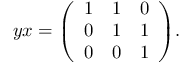<formula> <loc_0><loc_0><loc_500><loc_500>y x = { \left ( \begin{array} { l l l } { 1 } & { 1 } & { 0 } \\ { 0 } & { 1 } & { 1 } \\ { 0 } & { 0 } & { 1 } \end{array} \right ) } .</formula> 